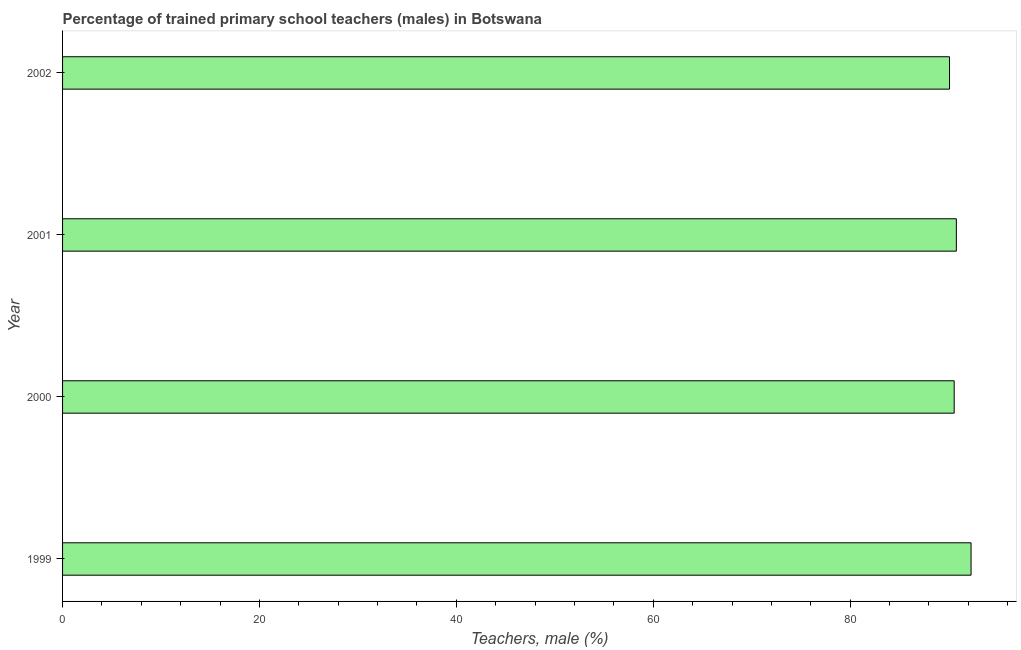Does the graph contain any zero values?
Your answer should be compact. No. Does the graph contain grids?
Make the answer very short. No. What is the title of the graph?
Your answer should be compact. Percentage of trained primary school teachers (males) in Botswana. What is the label or title of the X-axis?
Your response must be concise. Teachers, male (%). What is the percentage of trained male teachers in 2002?
Your answer should be compact. 90.09. Across all years, what is the maximum percentage of trained male teachers?
Your response must be concise. 92.28. Across all years, what is the minimum percentage of trained male teachers?
Provide a short and direct response. 90.09. What is the sum of the percentage of trained male teachers?
Keep it short and to the point. 363.73. What is the difference between the percentage of trained male teachers in 2000 and 2001?
Give a very brief answer. -0.22. What is the average percentage of trained male teachers per year?
Offer a very short reply. 90.93. What is the median percentage of trained male teachers?
Your answer should be very brief. 90.68. Do a majority of the years between 1999 and 2000 (inclusive) have percentage of trained male teachers greater than 60 %?
Offer a very short reply. Yes. Is the percentage of trained male teachers in 1999 less than that in 2000?
Your answer should be very brief. No. Is the difference between the percentage of trained male teachers in 2000 and 2002 greater than the difference between any two years?
Ensure brevity in your answer.  No. What is the difference between the highest and the second highest percentage of trained male teachers?
Your answer should be compact. 1.5. Is the sum of the percentage of trained male teachers in 2000 and 2002 greater than the maximum percentage of trained male teachers across all years?
Provide a succinct answer. Yes. What is the difference between the highest and the lowest percentage of trained male teachers?
Offer a very short reply. 2.19. Are the values on the major ticks of X-axis written in scientific E-notation?
Provide a succinct answer. No. What is the Teachers, male (%) in 1999?
Give a very brief answer. 92.28. What is the Teachers, male (%) in 2000?
Ensure brevity in your answer.  90.57. What is the Teachers, male (%) in 2001?
Give a very brief answer. 90.79. What is the Teachers, male (%) in 2002?
Give a very brief answer. 90.09. What is the difference between the Teachers, male (%) in 1999 and 2000?
Provide a succinct answer. 1.72. What is the difference between the Teachers, male (%) in 1999 and 2001?
Your response must be concise. 1.5. What is the difference between the Teachers, male (%) in 1999 and 2002?
Provide a short and direct response. 2.19. What is the difference between the Teachers, male (%) in 2000 and 2001?
Give a very brief answer. -0.22. What is the difference between the Teachers, male (%) in 2000 and 2002?
Your answer should be very brief. 0.47. What is the difference between the Teachers, male (%) in 2001 and 2002?
Your answer should be compact. 0.69. What is the ratio of the Teachers, male (%) in 1999 to that in 2000?
Your answer should be compact. 1.02. What is the ratio of the Teachers, male (%) in 2000 to that in 2001?
Provide a short and direct response. 1. 